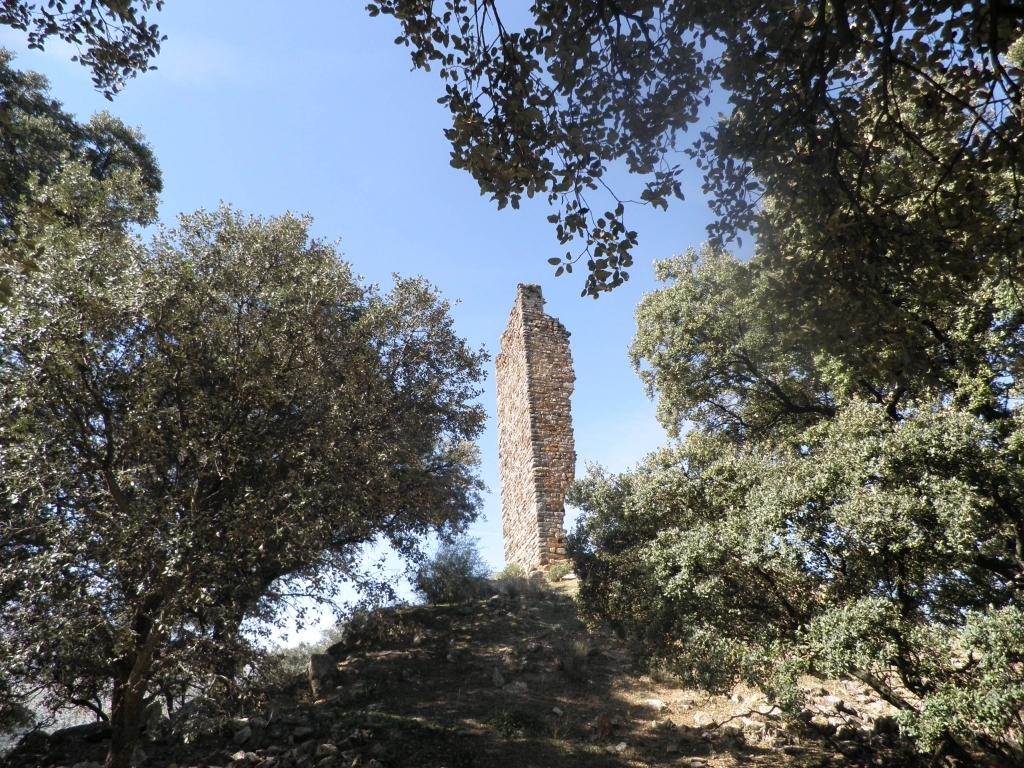In one or two sentences, can you explain what this image depicts? In this picture I can see trees and a brick wall and I can see a blue cloudy sky. 